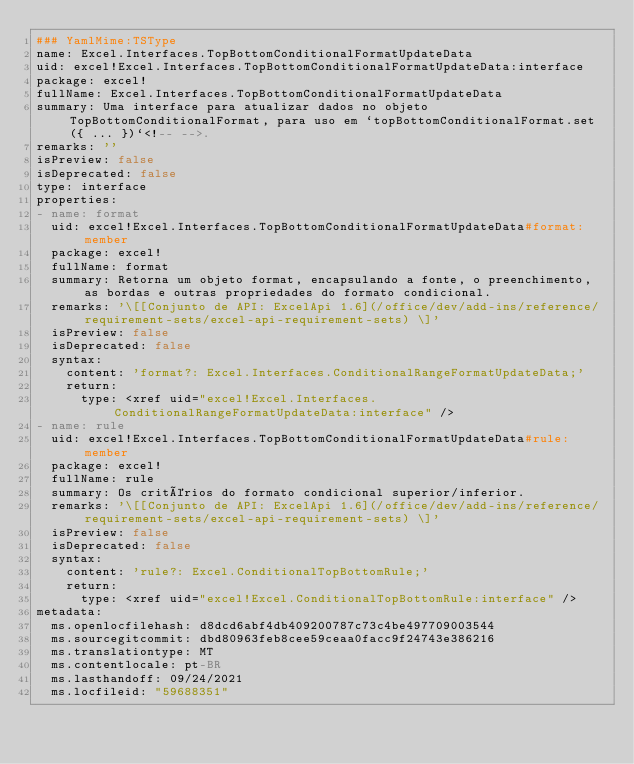Convert code to text. <code><loc_0><loc_0><loc_500><loc_500><_YAML_>### YamlMime:TSType
name: Excel.Interfaces.TopBottomConditionalFormatUpdateData
uid: excel!Excel.Interfaces.TopBottomConditionalFormatUpdateData:interface
package: excel!
fullName: Excel.Interfaces.TopBottomConditionalFormatUpdateData
summary: Uma interface para atualizar dados no objeto TopBottomConditionalFormat, para uso em `topBottomConditionalFormat.set({ ... })`<!-- -->.
remarks: ''
isPreview: false
isDeprecated: false
type: interface
properties:
- name: format
  uid: excel!Excel.Interfaces.TopBottomConditionalFormatUpdateData#format:member
  package: excel!
  fullName: format
  summary: Retorna um objeto format, encapsulando a fonte, o preenchimento, as bordas e outras propriedades do formato condicional.
  remarks: '\[[Conjunto de API: ExcelApi 1.6](/office/dev/add-ins/reference/requirement-sets/excel-api-requirement-sets) \]'
  isPreview: false
  isDeprecated: false
  syntax:
    content: 'format?: Excel.Interfaces.ConditionalRangeFormatUpdateData;'
    return:
      type: <xref uid="excel!Excel.Interfaces.ConditionalRangeFormatUpdateData:interface" />
- name: rule
  uid: excel!Excel.Interfaces.TopBottomConditionalFormatUpdateData#rule:member
  package: excel!
  fullName: rule
  summary: Os critérios do formato condicional superior/inferior.
  remarks: '\[[Conjunto de API: ExcelApi 1.6](/office/dev/add-ins/reference/requirement-sets/excel-api-requirement-sets) \]'
  isPreview: false
  isDeprecated: false
  syntax:
    content: 'rule?: Excel.ConditionalTopBottomRule;'
    return:
      type: <xref uid="excel!Excel.ConditionalTopBottomRule:interface" />
metadata:
  ms.openlocfilehash: d8dcd6abf4db409200787c73c4be497709003544
  ms.sourcegitcommit: dbd80963feb8cee59ceaa0facc9f24743e386216
  ms.translationtype: MT
  ms.contentlocale: pt-BR
  ms.lasthandoff: 09/24/2021
  ms.locfileid: "59688351"
</code> 